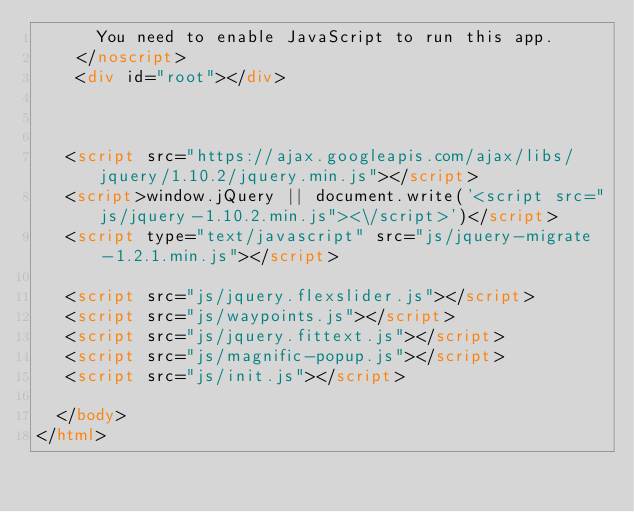<code> <loc_0><loc_0><loc_500><loc_500><_HTML_>      You need to enable JavaScript to run this app.
    </noscript>
    <div id="root"></div>



   <script src="https://ajax.googleapis.com/ajax/libs/jquery/1.10.2/jquery.min.js"></script>
   <script>window.jQuery || document.write('<script src="js/jquery-1.10.2.min.js"><\/script>')</script>
   <script type="text/javascript" src="js/jquery-migrate-1.2.1.min.js"></script>

   <script src="js/jquery.flexslider.js"></script>
   <script src="js/waypoints.js"></script>
   <script src="js/jquery.fittext.js"></script>
   <script src="js/magnific-popup.js"></script>
   <script src="js/init.js"></script>

  </body>
</html>
</code> 